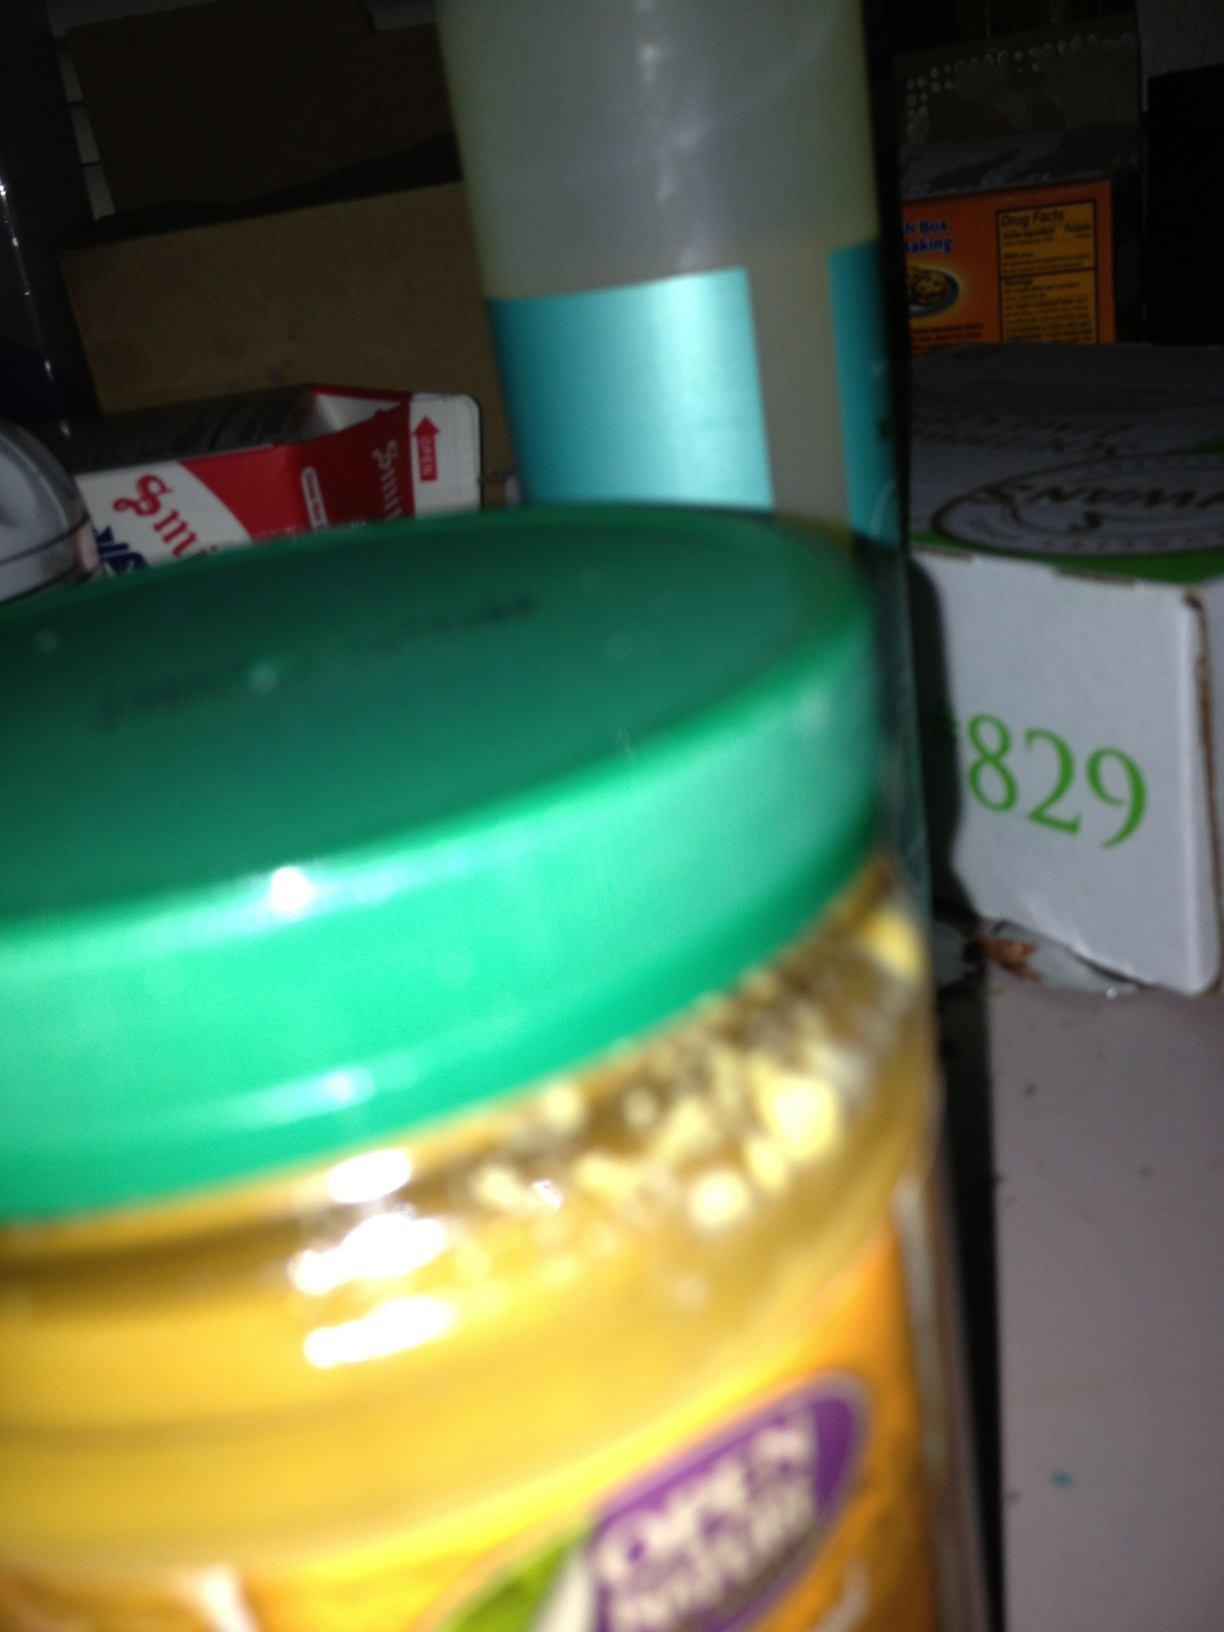If I wanted to clear up the image, what do you suggest I do? To improve the clarity of an image like this, ensuring good lighting and stability is crucial. Try to take the photo in a well-lit area, hold the camera steady, or use a surface to rest it on. Additionally, focus on the jar by tapping on it if you're using a smartphone, and make sure the camera lens is clean for the clearest possible picture.  What kind of jar is it, based on its shape and the lid? The jar in the image has a broad, rounded shape with a green lid, which is fairly typical for many food products. This form factor is commonly found in jars used for spreads or condiments, such as peanut butter, jams, or mustards, but without a clear image or label, it's difficult to know the exact use of this particular jar. 